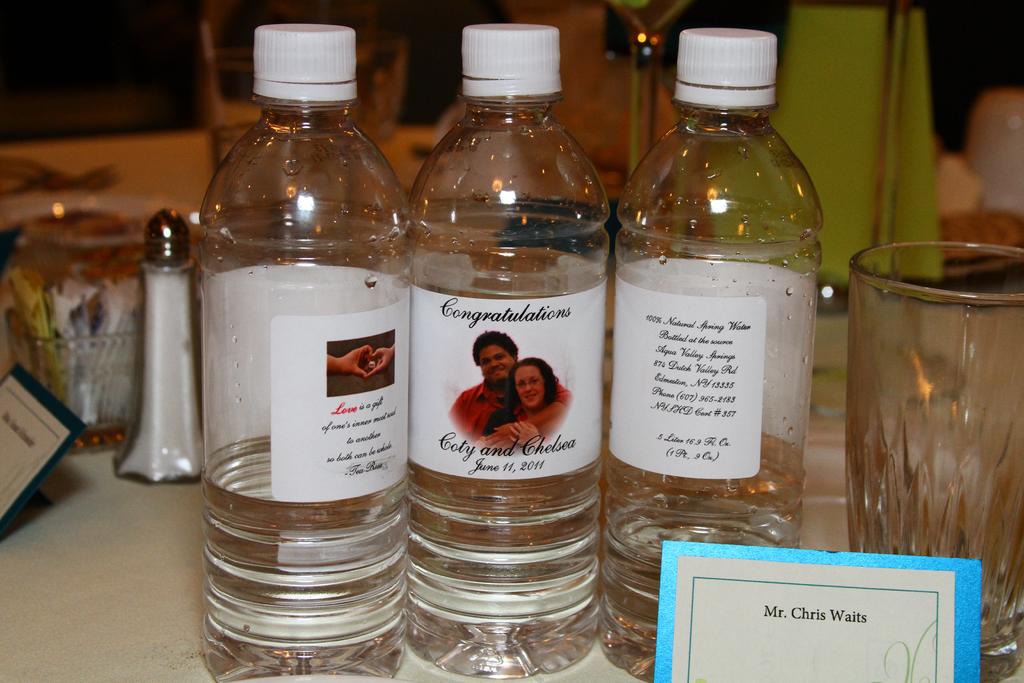What does it say on the middle water bottle?
Offer a terse response. Congratulations. 